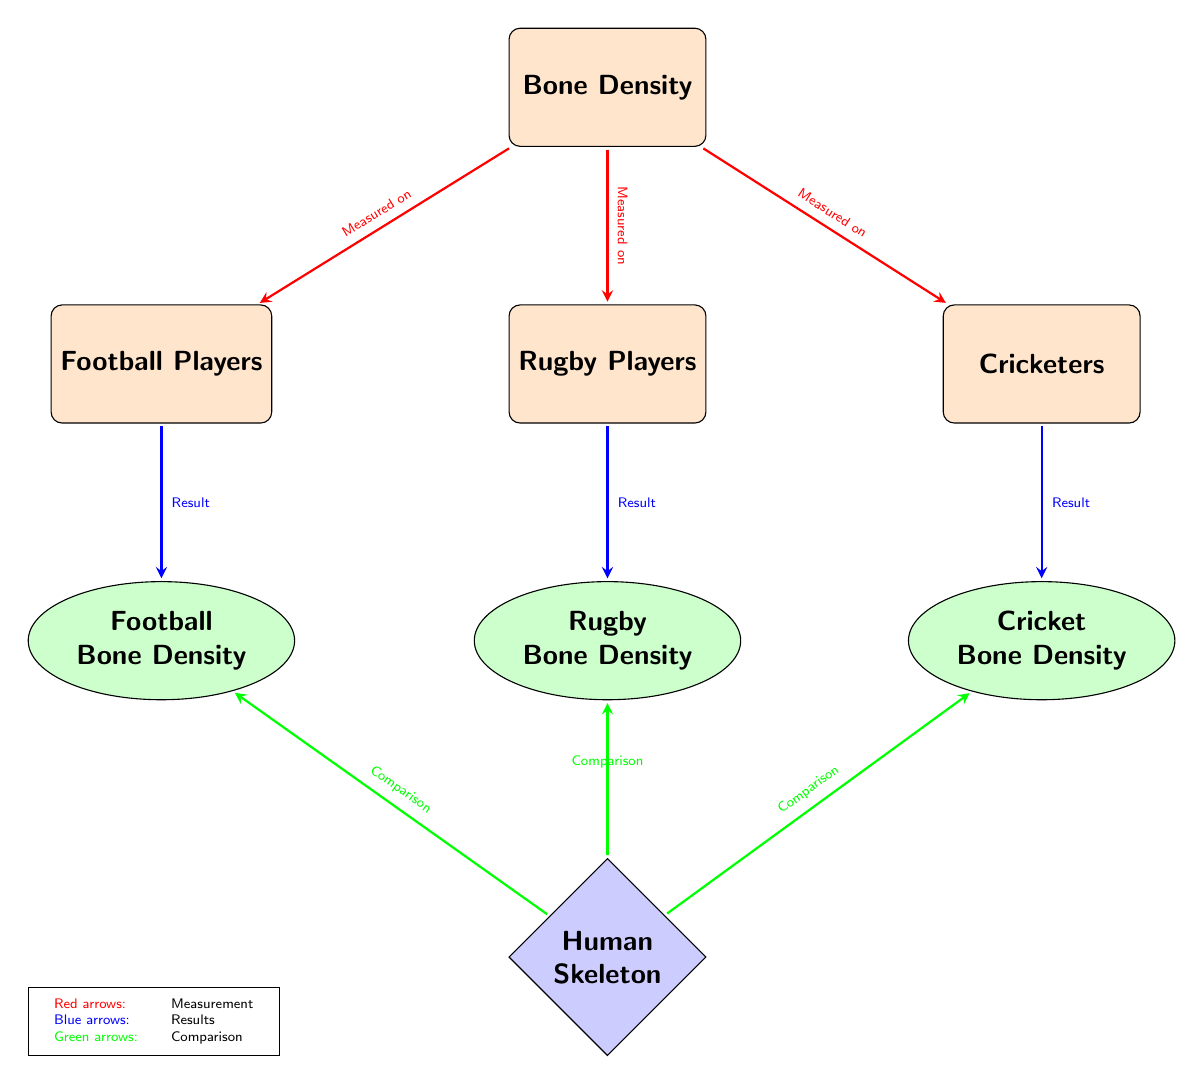What are the three types of athletes compared in the diagram? The diagram displays three types of athletes: Football Players, Rugby Players, and Cricketers.
Answer: Football Players, Rugby Players, Cricketers How many nodes represent the sports type in the diagram? There are three distinct nodes representing different sports types: Football Players, Rugby Players, and Cricketers.
Answer: 3 What color are the arrows that indicate measurement? The arrows that indicate measurement are colored red, as explained in the legend of the diagram.
Answer: Red Which athletes have the result labeled "Rugby Bone Density"? The Rugby Players node leads to the Rugby Bone Density result, as indicated by the blue arrow pointing downwards from the Rugby Players node.
Answer: Rugby Players What is the shape of the node representing the Human Skeleton? The Human Skeleton is represented by a diamond-shaped node in blue, as specified by the shape definition in the diagram.
Answer: Diamond What comparison is made with the results of bone density? The comparison nodes connected to the Rugby Bone Density result indicate that comparisons are made with the Human Skeleton, analyzed across all sports types.
Answer: Comparison Which arrow color indicates comparisons in the diagram? The arrows displaying comparisons are colored green, according to the legend in the diagram.
Answer: Green How many results are shown in the diagram? There are three results shown: Football Bone Density, Rugby Bone Density, and Cricket Bone Density, each leading from their respective athlete nodes.
Answer: 3 